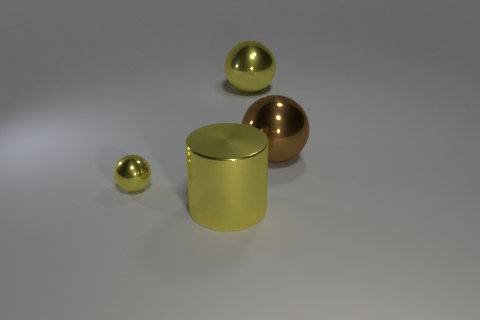Is there any other thing of the same color as the small thing?
Ensure brevity in your answer.  Yes. Is the color of the cylinder the same as the tiny metallic object?
Provide a succinct answer. Yes. Is the color of the object that is to the left of the yellow metal cylinder the same as the cylinder?
Make the answer very short. Yes. There is a yellow sphere in front of the metallic object behind the brown shiny sphere; what is its size?
Keep it short and to the point. Small. Is there a tiny sphere of the same color as the metal cylinder?
Your answer should be compact. Yes. Are there the same number of yellow metallic cylinders in front of the large metal cylinder and small red rubber cylinders?
Your answer should be very brief. Yes. What number of large red metallic objects are there?
Ensure brevity in your answer.  0. The thing that is on the right side of the tiny metallic thing and in front of the big brown metal ball has what shape?
Ensure brevity in your answer.  Cylinder. There is a big thing that is in front of the small yellow metallic object; does it have the same color as the shiny sphere that is left of the cylinder?
Your answer should be compact. Yes. What size is the cylinder that is the same color as the tiny metallic ball?
Your answer should be compact. Large. 